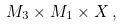<formula> <loc_0><loc_0><loc_500><loc_500>M _ { 3 } \times M _ { 1 } \times X \, ,</formula> 